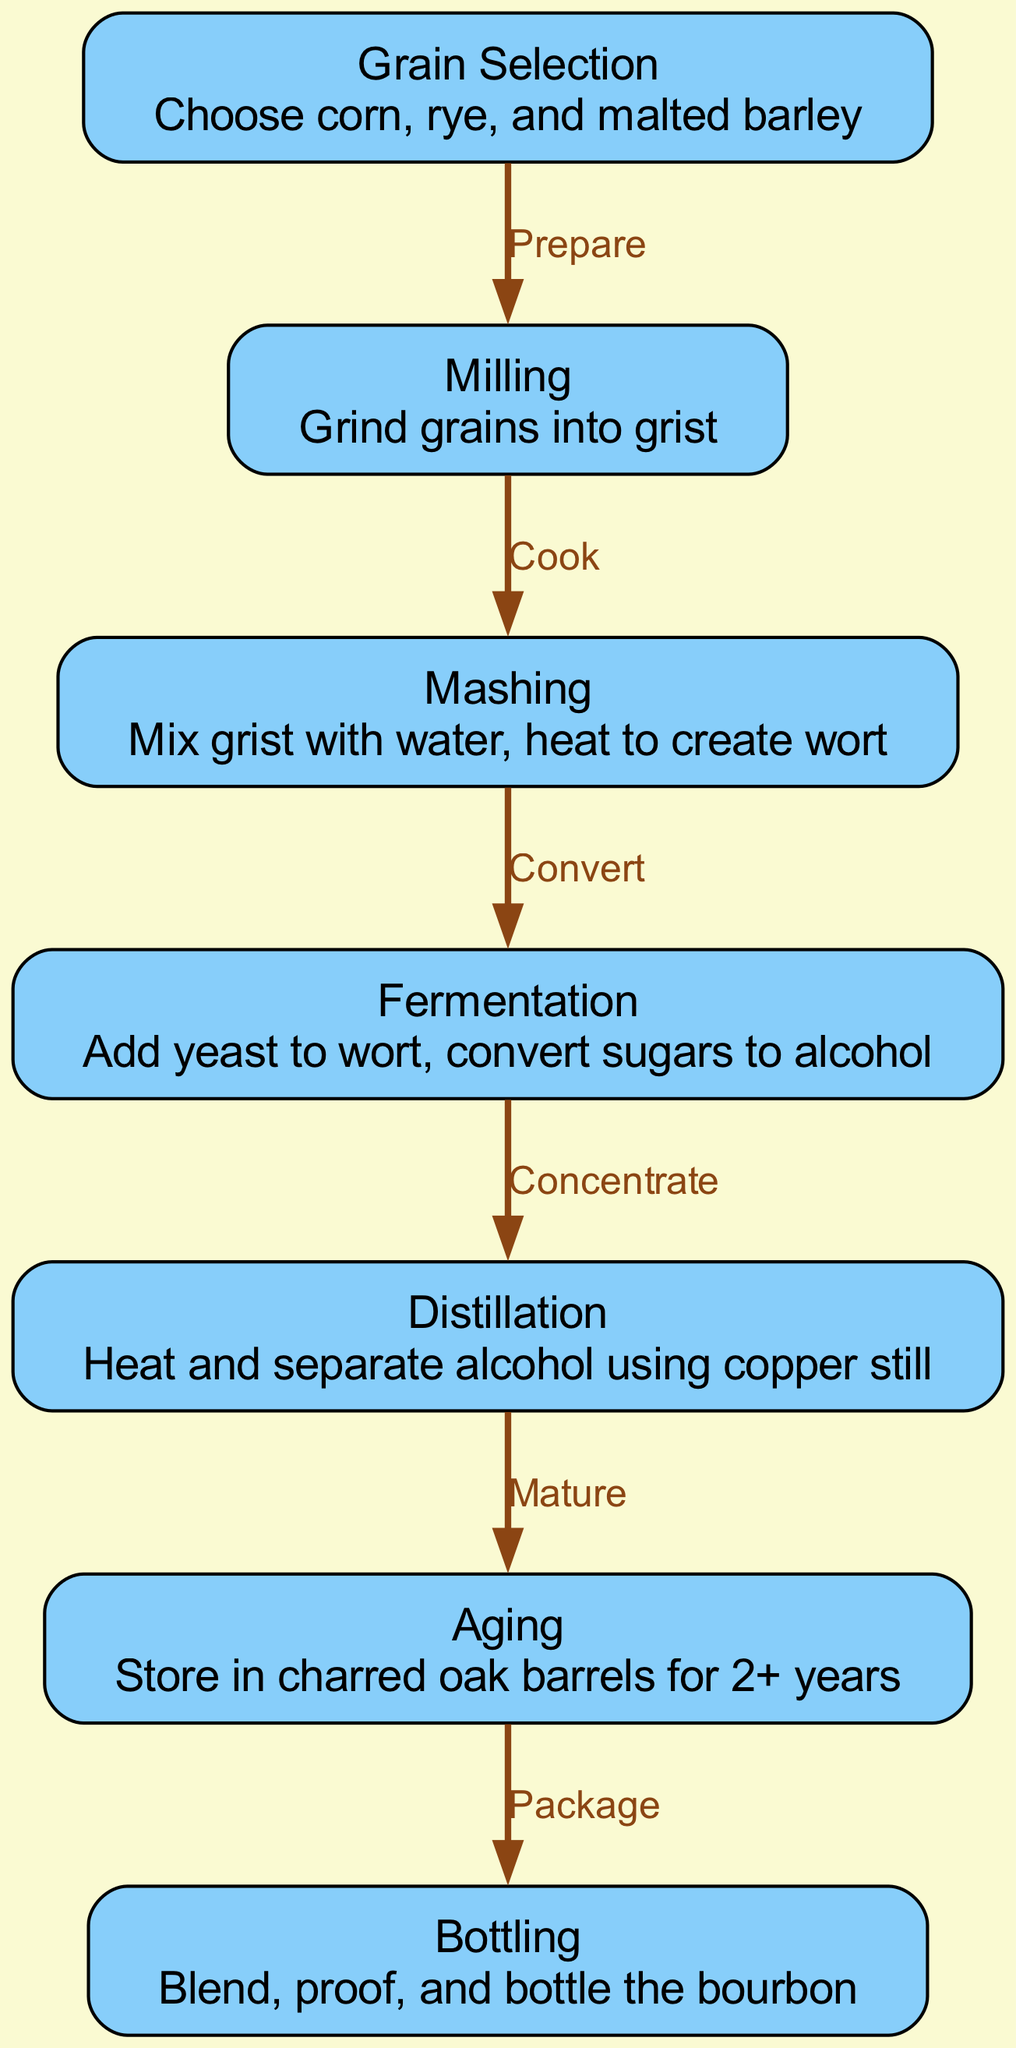What is the first step in the bourbon distillation process? The first step in the diagram is "Grain Selection" which involves choosing the grains like corn, rye, and malted barley.
Answer: Grain Selection How many steps are there in the bourbon distillation process? By counting the nodes in the diagram, there are a total of 7 steps in the bourbon distillation process.
Answer: 7 What is the purpose of the "Mashing" step? The "Mashing" step involves mixing grist with water and heating it to create wort, which is an essential precursor for fermentation.
Answer: Create wort Which step follows "Fermentation"? The step that follows "Fermentation" is "Distillation", as the edges indicate the flow from one step to the next.
Answer: Distillation What is the final stage of the bourbon distillation process? The final stage in the diagram is "Bottling", which is where the bourbon is blended, proofed, and bottled for sale.
Answer: Bottling What is the relationship between "Distillation" and "Aging"? The relationship shows that after "Distillation", the bourbon is then subjected to "Aging" where it is stored in charred oak barrels.
Answer: Mature What is stored in charred oak barrels? The bourbon is stored in charred oak barrels during the "Aging" step which lasts for 2 or more years.
Answer: Bourbon How does fermentation contribute to bourbon production? In the "Fermentation" step, yeast is added to wort to convert sugars into alcohol, crucial for bourbon's production.
Answer: Convert sugars to alcohol 